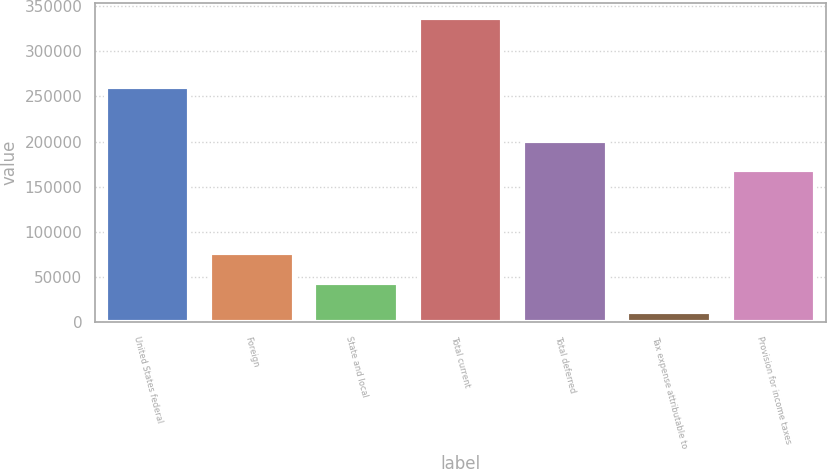Convert chart. <chart><loc_0><loc_0><loc_500><loc_500><bar_chart><fcel>United States federal<fcel>Foreign<fcel>State and local<fcel>Total current<fcel>Total deferred<fcel>Tax expense attributable to<fcel>Provision for income taxes<nl><fcel>260118<fcel>76257<fcel>43682.5<fcel>336853<fcel>201046<fcel>11108<fcel>168471<nl></chart> 